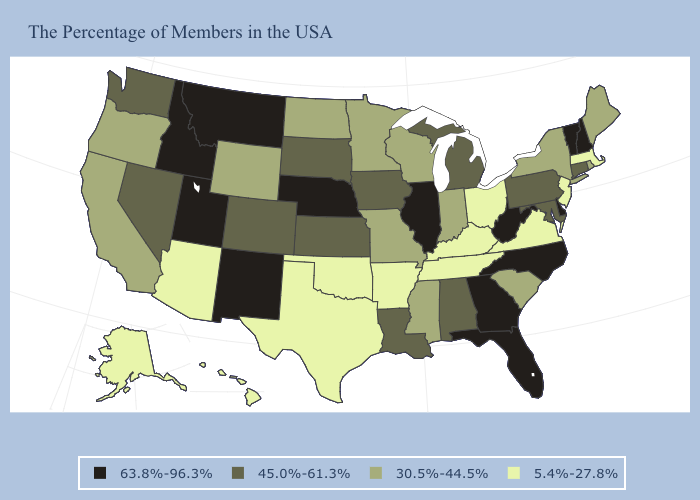What is the lowest value in states that border Mississippi?
Short answer required. 5.4%-27.8%. Name the states that have a value in the range 5.4%-27.8%?
Write a very short answer. Massachusetts, New Jersey, Virginia, Ohio, Kentucky, Tennessee, Arkansas, Oklahoma, Texas, Arizona, Alaska, Hawaii. What is the highest value in the USA?
Quick response, please. 63.8%-96.3%. What is the highest value in the USA?
Keep it brief. 63.8%-96.3%. Does Virginia have the lowest value in the USA?
Be succinct. Yes. Name the states that have a value in the range 45.0%-61.3%?
Answer briefly. Connecticut, Maryland, Pennsylvania, Michigan, Alabama, Louisiana, Iowa, Kansas, South Dakota, Colorado, Nevada, Washington. What is the lowest value in states that border Michigan?
Answer briefly. 5.4%-27.8%. Name the states that have a value in the range 45.0%-61.3%?
Keep it brief. Connecticut, Maryland, Pennsylvania, Michigan, Alabama, Louisiana, Iowa, Kansas, South Dakota, Colorado, Nevada, Washington. What is the value of Tennessee?
Give a very brief answer. 5.4%-27.8%. Does Tennessee have the lowest value in the USA?
Give a very brief answer. Yes. What is the lowest value in the USA?
Give a very brief answer. 5.4%-27.8%. Does the first symbol in the legend represent the smallest category?
Quick response, please. No. Does Illinois have the highest value in the USA?
Concise answer only. Yes. Does New Mexico have the lowest value in the USA?
Be succinct. No. Name the states that have a value in the range 63.8%-96.3%?
Keep it brief. New Hampshire, Vermont, Delaware, North Carolina, West Virginia, Florida, Georgia, Illinois, Nebraska, New Mexico, Utah, Montana, Idaho. 